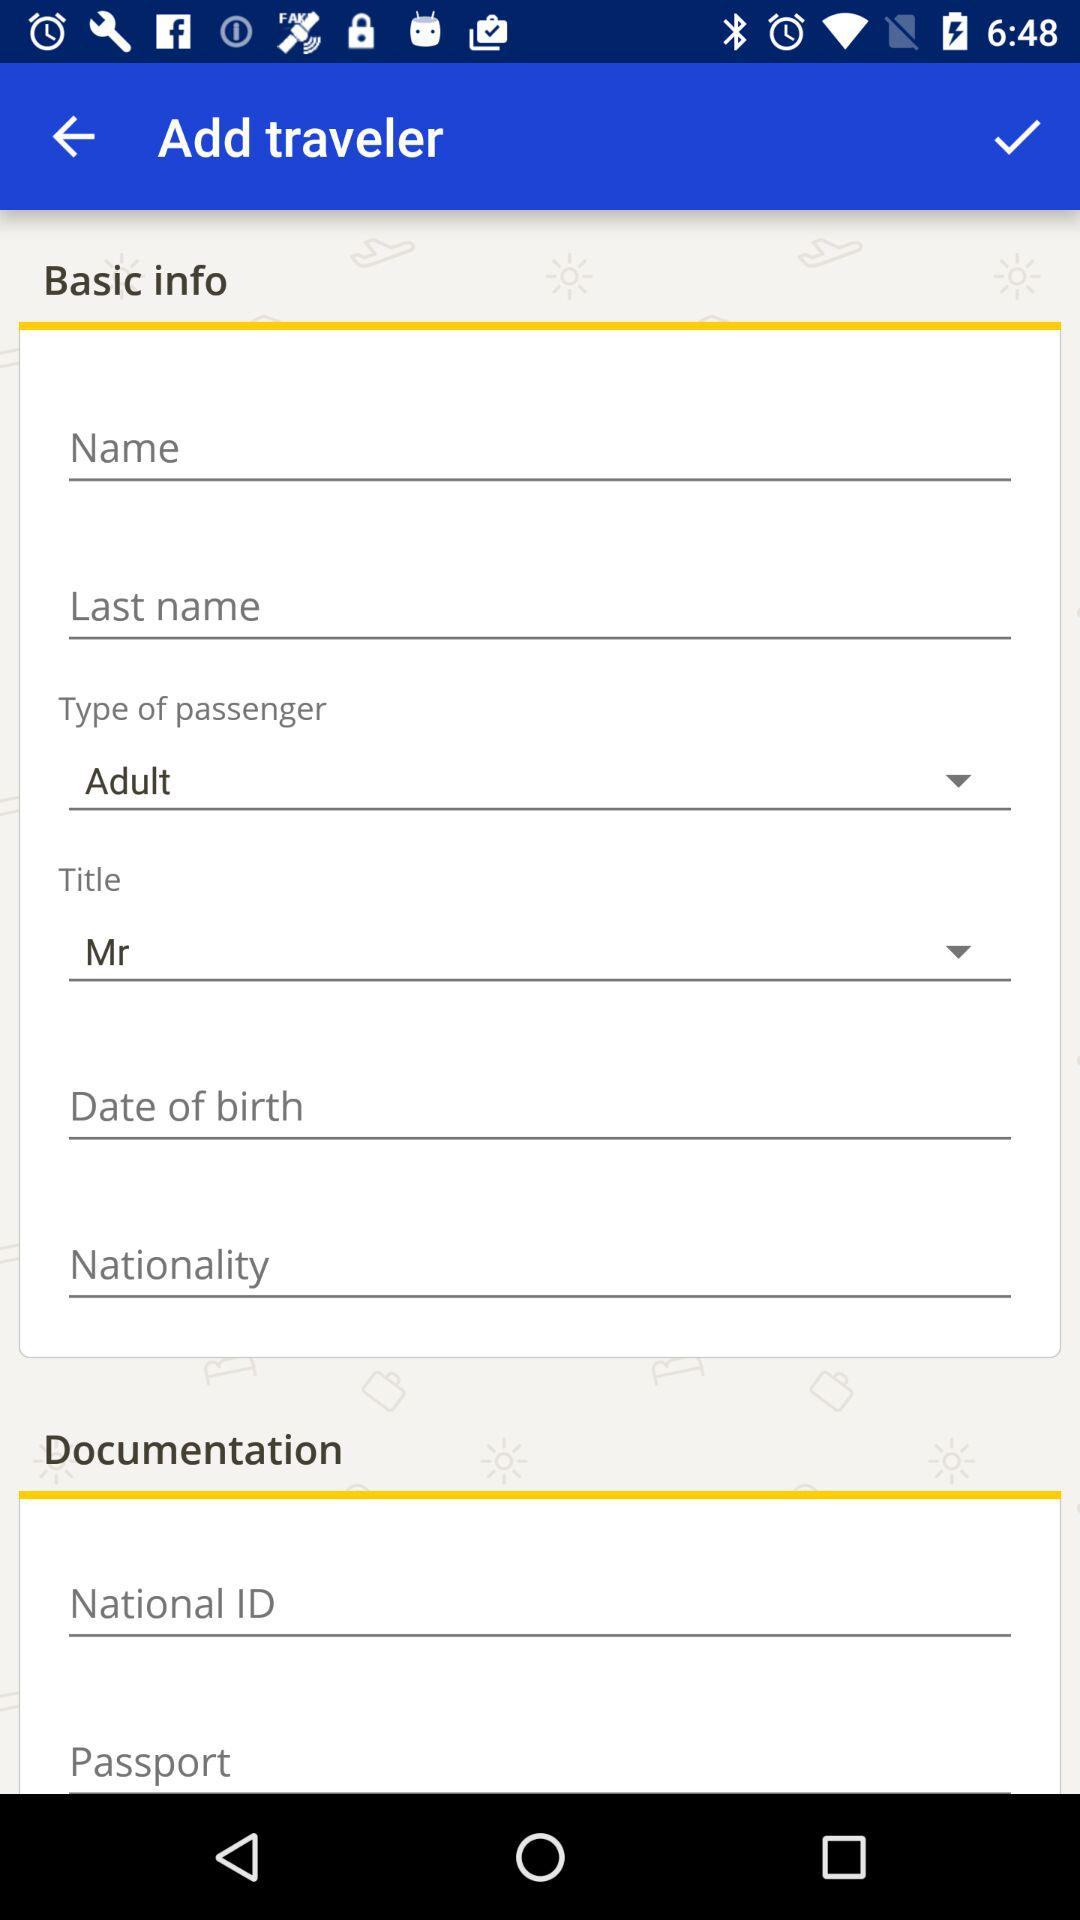How many text inputs are there for the passenger's documentation?
Answer the question using a single word or phrase. 2 